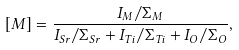Convert formula to latex. <formula><loc_0><loc_0><loc_500><loc_500>[ M ] = \frac { I _ { M } / \Sigma _ { M } } { I _ { S r } / \Sigma _ { S r } + I _ { T i } / \Sigma _ { T i } + I _ { O } / \Sigma _ { O } } ,</formula> 